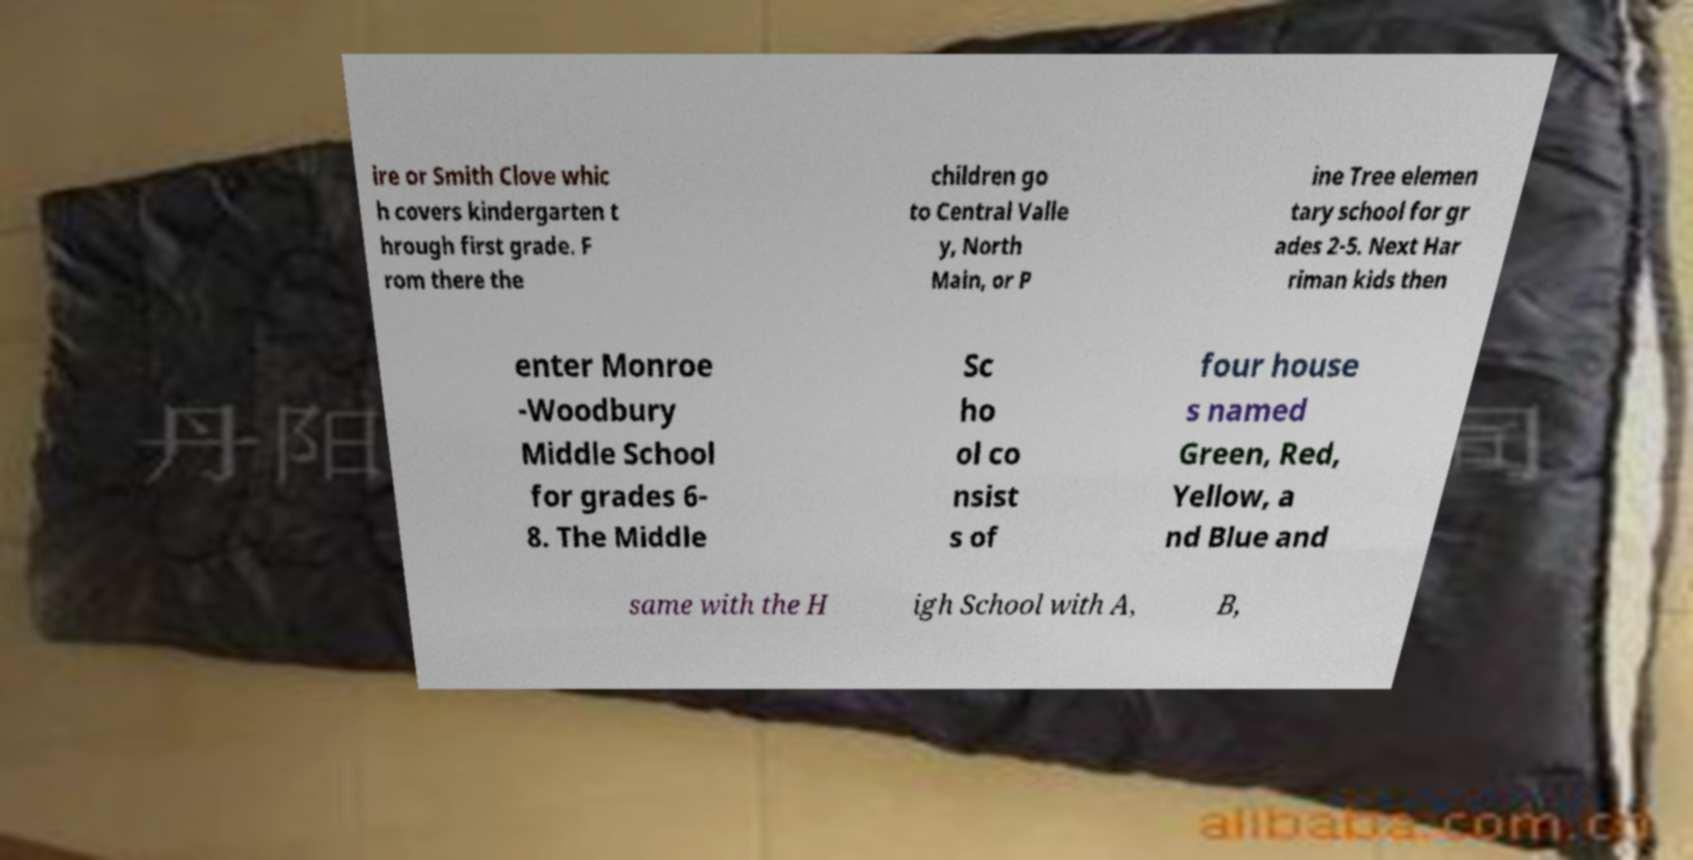I need the written content from this picture converted into text. Can you do that? ire or Smith Clove whic h covers kindergarten t hrough first grade. F rom there the children go to Central Valle y, North Main, or P ine Tree elemen tary school for gr ades 2-5. Next Har riman kids then enter Monroe -Woodbury Middle School for grades 6- 8. The Middle Sc ho ol co nsist s of four house s named Green, Red, Yellow, a nd Blue and same with the H igh School with A, B, 